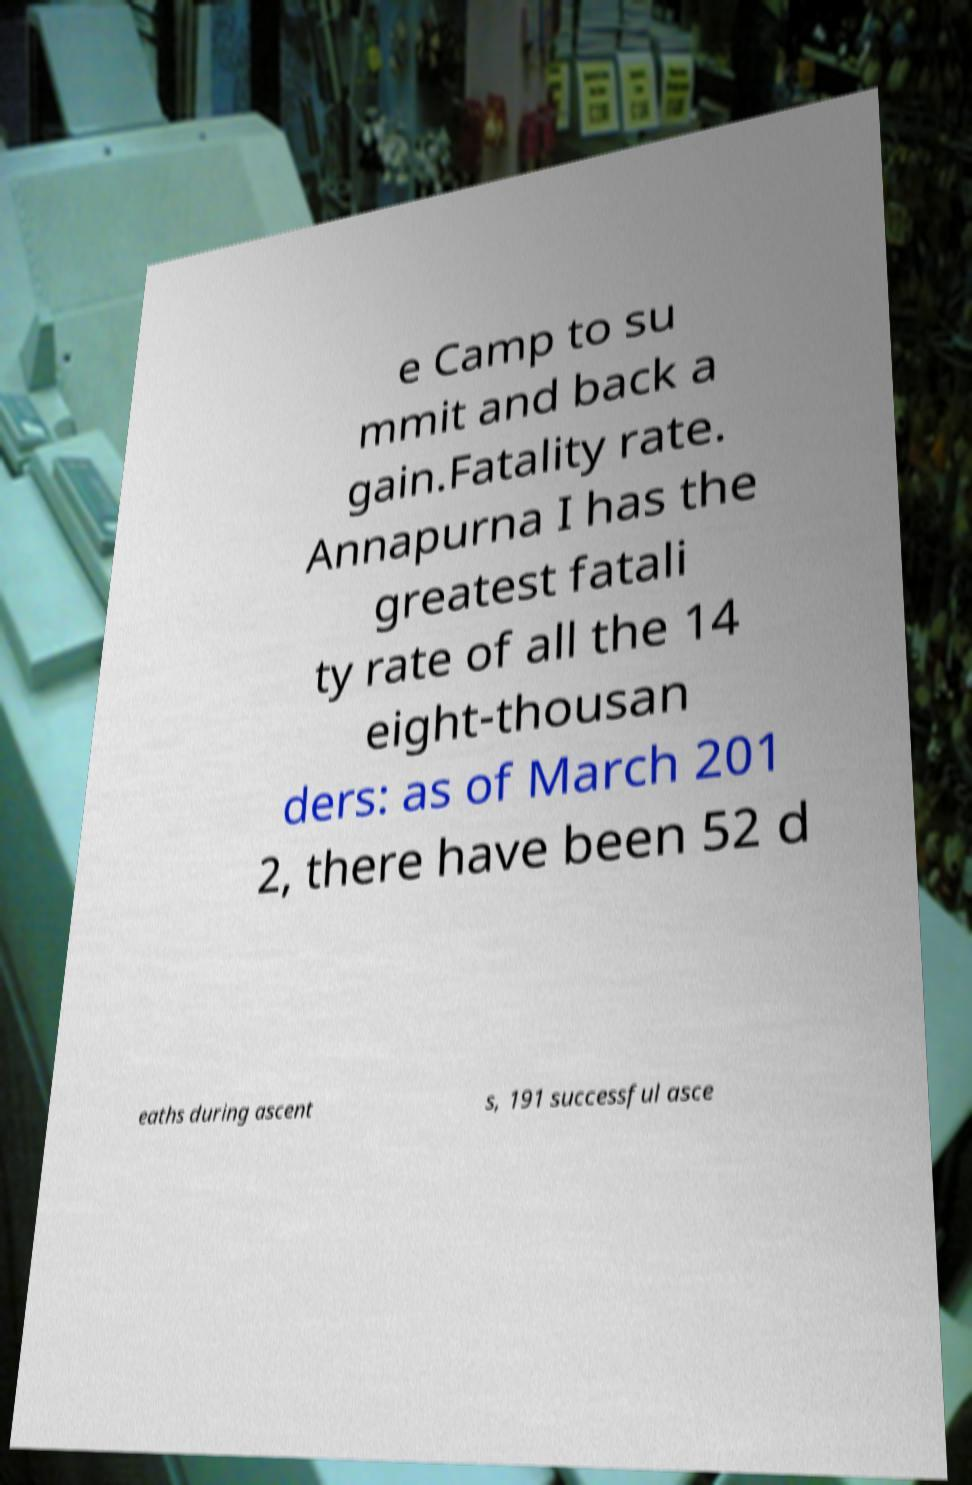For documentation purposes, I need the text within this image transcribed. Could you provide that? e Camp to su mmit and back a gain.Fatality rate. Annapurna I has the greatest fatali ty rate of all the 14 eight-thousan ders: as of March 201 2, there have been 52 d eaths during ascent s, 191 successful asce 